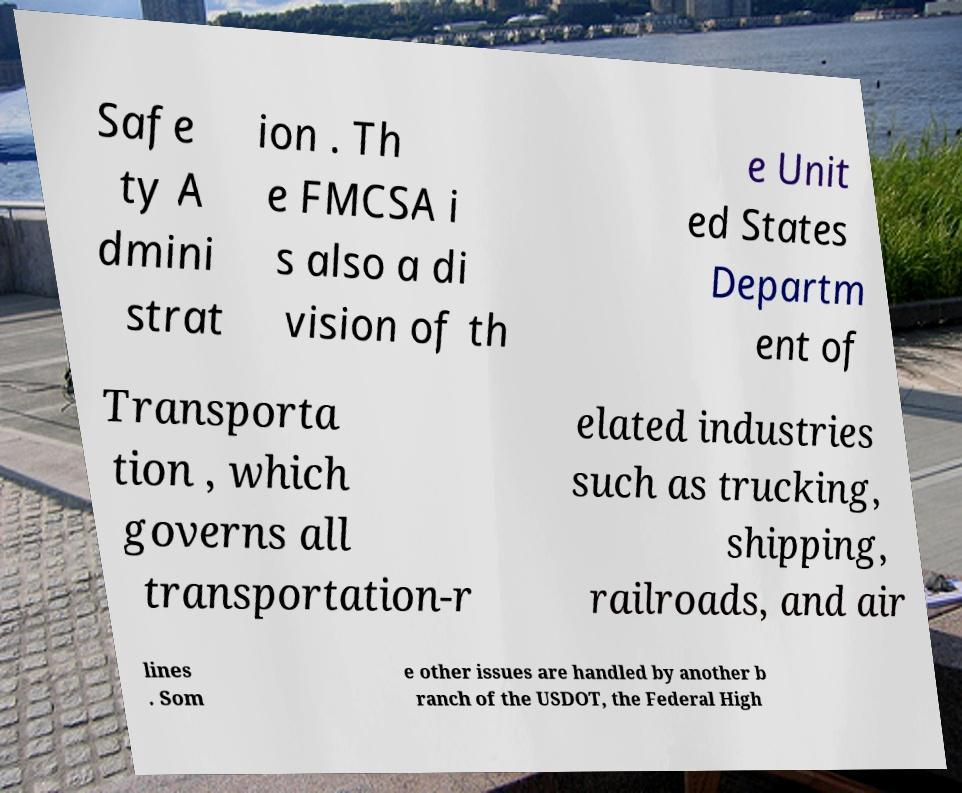There's text embedded in this image that I need extracted. Can you transcribe it verbatim? Safe ty A dmini strat ion . Th e FMCSA i s also a di vision of th e Unit ed States Departm ent of Transporta tion , which governs all transportation-r elated industries such as trucking, shipping, railroads, and air lines . Som e other issues are handled by another b ranch of the USDOT, the Federal High 